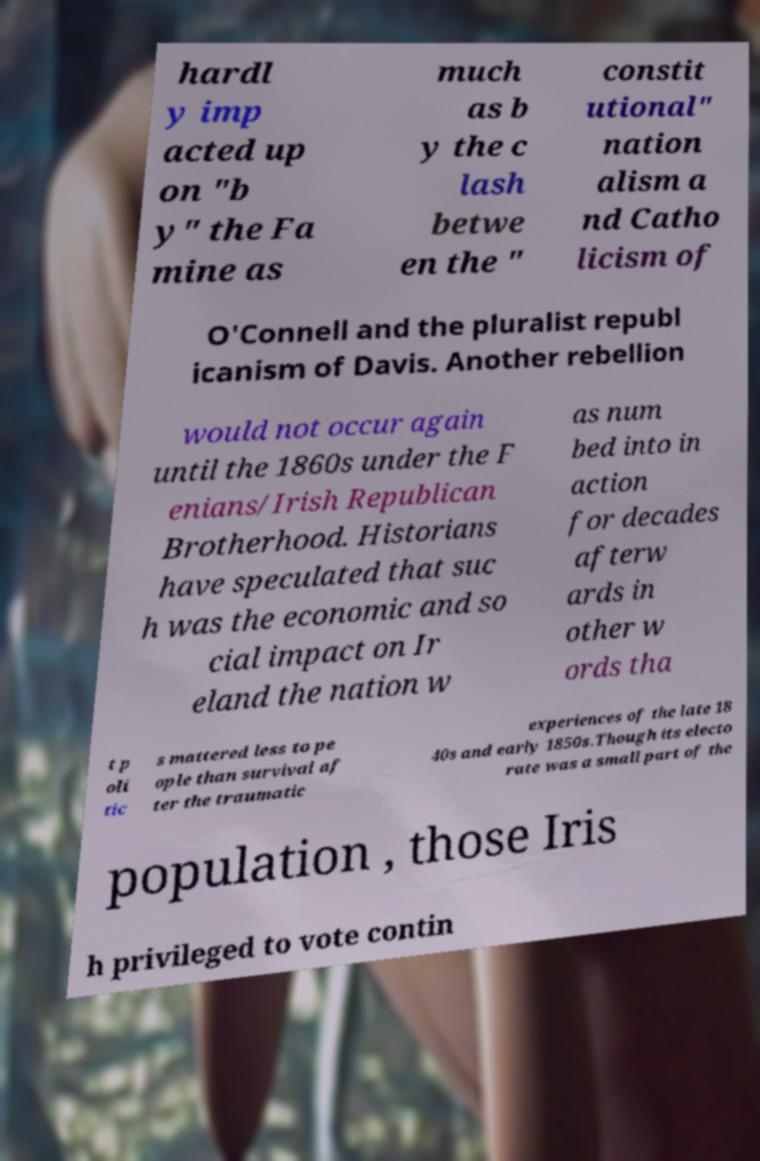There's text embedded in this image that I need extracted. Can you transcribe it verbatim? hardl y imp acted up on "b y" the Fa mine as much as b y the c lash betwe en the " constit utional" nation alism a nd Catho licism of O'Connell and the pluralist republ icanism of Davis. Another rebellion would not occur again until the 1860s under the F enians/Irish Republican Brotherhood. Historians have speculated that suc h was the economic and so cial impact on Ir eland the nation w as num bed into in action for decades afterw ards in other w ords tha t p oli tic s mattered less to pe ople than survival af ter the traumatic experiences of the late 18 40s and early 1850s.Though its electo rate was a small part of the population , those Iris h privileged to vote contin 